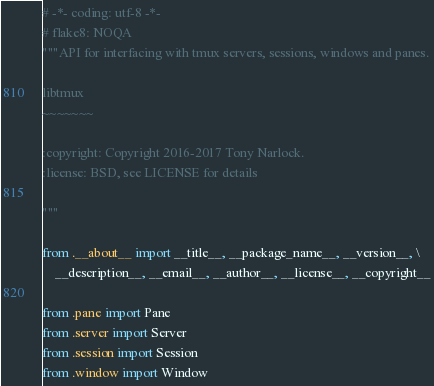Convert code to text. <code><loc_0><loc_0><loc_500><loc_500><_Python_># -*- coding: utf-8 -*-
# flake8: NOQA
"""API for interfacing with tmux servers, sessions, windows and panes.

libtmux
~~~~~~~

:copyright: Copyright 2016-2017 Tony Narlock.
:license: BSD, see LICENSE for details

"""

from .__about__ import __title__, __package_name__, __version__, \
    __description__, __email__, __author__, __license__, __copyright__

from .pane import Pane
from .server import Server
from .session import Session
from .window import Window
</code> 